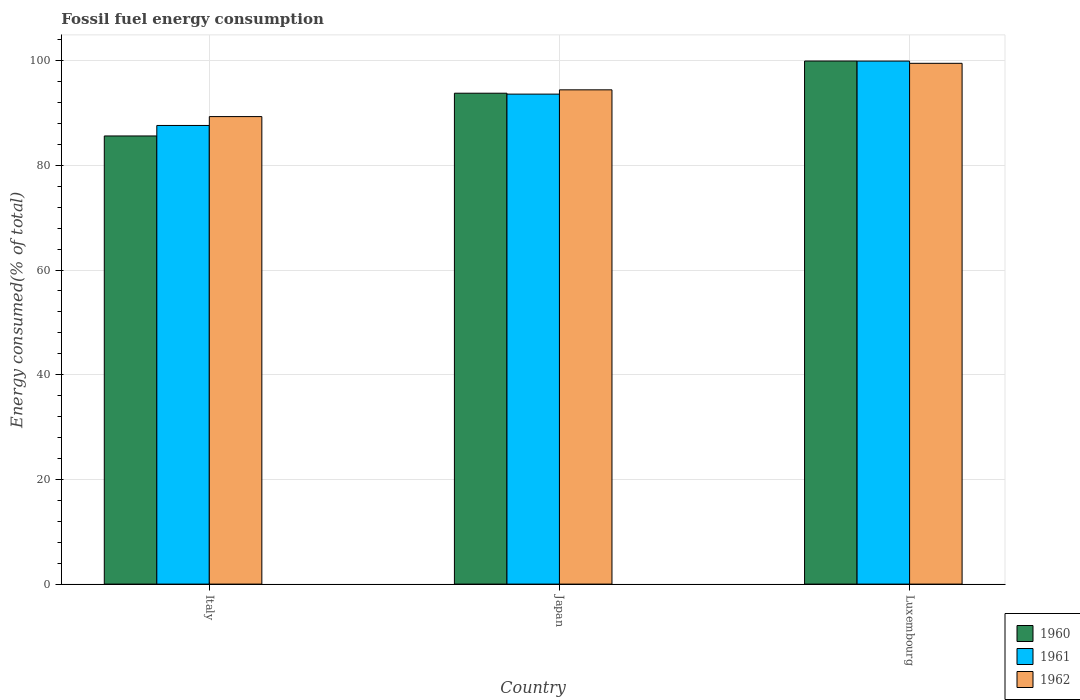How many groups of bars are there?
Make the answer very short. 3. Are the number of bars on each tick of the X-axis equal?
Keep it short and to the point. Yes. How many bars are there on the 3rd tick from the left?
Ensure brevity in your answer.  3. In how many cases, is the number of bars for a given country not equal to the number of legend labels?
Offer a very short reply. 0. What is the percentage of energy consumed in 1960 in Japan?
Ensure brevity in your answer.  93.78. Across all countries, what is the maximum percentage of energy consumed in 1960?
Keep it short and to the point. 99.92. Across all countries, what is the minimum percentage of energy consumed in 1962?
Make the answer very short. 89.31. In which country was the percentage of energy consumed in 1962 maximum?
Your response must be concise. Luxembourg. In which country was the percentage of energy consumed in 1960 minimum?
Your answer should be compact. Italy. What is the total percentage of energy consumed in 1961 in the graph?
Offer a terse response. 281.13. What is the difference between the percentage of energy consumed in 1960 in Japan and that in Luxembourg?
Offer a very short reply. -6.15. What is the difference between the percentage of energy consumed in 1961 in Italy and the percentage of energy consumed in 1962 in Luxembourg?
Offer a very short reply. -11.87. What is the average percentage of energy consumed in 1961 per country?
Your response must be concise. 93.71. What is the difference between the percentage of energy consumed of/in 1961 and percentage of energy consumed of/in 1962 in Japan?
Your answer should be very brief. -0.82. In how many countries, is the percentage of energy consumed in 1960 greater than 68 %?
Your answer should be very brief. 3. What is the ratio of the percentage of energy consumed in 1960 in Italy to that in Japan?
Offer a terse response. 0.91. Is the difference between the percentage of energy consumed in 1961 in Japan and Luxembourg greater than the difference between the percentage of energy consumed in 1962 in Japan and Luxembourg?
Your answer should be very brief. No. What is the difference between the highest and the second highest percentage of energy consumed in 1960?
Provide a short and direct response. 14.31. What is the difference between the highest and the lowest percentage of energy consumed in 1961?
Make the answer very short. 12.3. What does the 1st bar from the left in Italy represents?
Make the answer very short. 1960. What does the 3rd bar from the right in Luxembourg represents?
Your response must be concise. 1960. Is it the case that in every country, the sum of the percentage of energy consumed in 1962 and percentage of energy consumed in 1960 is greater than the percentage of energy consumed in 1961?
Keep it short and to the point. Yes. How many countries are there in the graph?
Provide a succinct answer. 3. What is the difference between two consecutive major ticks on the Y-axis?
Provide a short and direct response. 20. Are the values on the major ticks of Y-axis written in scientific E-notation?
Make the answer very short. No. Does the graph contain any zero values?
Offer a terse response. No. What is the title of the graph?
Give a very brief answer. Fossil fuel energy consumption. Does "1977" appear as one of the legend labels in the graph?
Make the answer very short. No. What is the label or title of the X-axis?
Give a very brief answer. Country. What is the label or title of the Y-axis?
Ensure brevity in your answer.  Energy consumed(% of total). What is the Energy consumed(% of total) of 1960 in Italy?
Make the answer very short. 85.61. What is the Energy consumed(% of total) in 1961 in Italy?
Provide a succinct answer. 87.62. What is the Energy consumed(% of total) in 1962 in Italy?
Provide a short and direct response. 89.31. What is the Energy consumed(% of total) of 1960 in Japan?
Your response must be concise. 93.78. What is the Energy consumed(% of total) in 1961 in Japan?
Your answer should be compact. 93.6. What is the Energy consumed(% of total) in 1962 in Japan?
Your response must be concise. 94.42. What is the Energy consumed(% of total) of 1960 in Luxembourg?
Make the answer very short. 99.92. What is the Energy consumed(% of total) of 1961 in Luxembourg?
Your answer should be very brief. 99.91. What is the Energy consumed(% of total) in 1962 in Luxembourg?
Your answer should be compact. 99.49. Across all countries, what is the maximum Energy consumed(% of total) in 1960?
Provide a succinct answer. 99.92. Across all countries, what is the maximum Energy consumed(% of total) in 1961?
Provide a succinct answer. 99.91. Across all countries, what is the maximum Energy consumed(% of total) of 1962?
Provide a succinct answer. 99.49. Across all countries, what is the minimum Energy consumed(% of total) in 1960?
Keep it short and to the point. 85.61. Across all countries, what is the minimum Energy consumed(% of total) in 1961?
Your answer should be very brief. 87.62. Across all countries, what is the minimum Energy consumed(% of total) in 1962?
Offer a terse response. 89.31. What is the total Energy consumed(% of total) in 1960 in the graph?
Keep it short and to the point. 279.31. What is the total Energy consumed(% of total) in 1961 in the graph?
Give a very brief answer. 281.13. What is the total Energy consumed(% of total) of 1962 in the graph?
Make the answer very short. 283.22. What is the difference between the Energy consumed(% of total) in 1960 in Italy and that in Japan?
Keep it short and to the point. -8.17. What is the difference between the Energy consumed(% of total) in 1961 in Italy and that in Japan?
Offer a terse response. -5.99. What is the difference between the Energy consumed(% of total) in 1962 in Italy and that in Japan?
Offer a very short reply. -5.11. What is the difference between the Energy consumed(% of total) in 1960 in Italy and that in Luxembourg?
Your answer should be compact. -14.31. What is the difference between the Energy consumed(% of total) in 1961 in Italy and that in Luxembourg?
Ensure brevity in your answer.  -12.3. What is the difference between the Energy consumed(% of total) in 1962 in Italy and that in Luxembourg?
Offer a very short reply. -10.18. What is the difference between the Energy consumed(% of total) in 1960 in Japan and that in Luxembourg?
Provide a succinct answer. -6.15. What is the difference between the Energy consumed(% of total) of 1961 in Japan and that in Luxembourg?
Your answer should be compact. -6.31. What is the difference between the Energy consumed(% of total) of 1962 in Japan and that in Luxembourg?
Offer a very short reply. -5.07. What is the difference between the Energy consumed(% of total) of 1960 in Italy and the Energy consumed(% of total) of 1961 in Japan?
Make the answer very short. -7.99. What is the difference between the Energy consumed(% of total) of 1960 in Italy and the Energy consumed(% of total) of 1962 in Japan?
Give a very brief answer. -8.81. What is the difference between the Energy consumed(% of total) of 1961 in Italy and the Energy consumed(% of total) of 1962 in Japan?
Your answer should be very brief. -6.8. What is the difference between the Energy consumed(% of total) of 1960 in Italy and the Energy consumed(% of total) of 1961 in Luxembourg?
Make the answer very short. -14.3. What is the difference between the Energy consumed(% of total) of 1960 in Italy and the Energy consumed(% of total) of 1962 in Luxembourg?
Offer a terse response. -13.88. What is the difference between the Energy consumed(% of total) of 1961 in Italy and the Energy consumed(% of total) of 1962 in Luxembourg?
Your answer should be compact. -11.87. What is the difference between the Energy consumed(% of total) in 1960 in Japan and the Energy consumed(% of total) in 1961 in Luxembourg?
Provide a succinct answer. -6.14. What is the difference between the Energy consumed(% of total) of 1960 in Japan and the Energy consumed(% of total) of 1962 in Luxembourg?
Provide a short and direct response. -5.71. What is the difference between the Energy consumed(% of total) in 1961 in Japan and the Energy consumed(% of total) in 1962 in Luxembourg?
Offer a very short reply. -5.88. What is the average Energy consumed(% of total) in 1960 per country?
Your response must be concise. 93.1. What is the average Energy consumed(% of total) of 1961 per country?
Provide a succinct answer. 93.71. What is the average Energy consumed(% of total) in 1962 per country?
Your answer should be compact. 94.41. What is the difference between the Energy consumed(% of total) of 1960 and Energy consumed(% of total) of 1961 in Italy?
Ensure brevity in your answer.  -2.01. What is the difference between the Energy consumed(% of total) of 1960 and Energy consumed(% of total) of 1962 in Italy?
Make the answer very short. -3.7. What is the difference between the Energy consumed(% of total) in 1961 and Energy consumed(% of total) in 1962 in Italy?
Offer a terse response. -1.69. What is the difference between the Energy consumed(% of total) of 1960 and Energy consumed(% of total) of 1961 in Japan?
Your answer should be very brief. 0.17. What is the difference between the Energy consumed(% of total) of 1960 and Energy consumed(% of total) of 1962 in Japan?
Offer a terse response. -0.64. What is the difference between the Energy consumed(% of total) in 1961 and Energy consumed(% of total) in 1962 in Japan?
Provide a short and direct response. -0.82. What is the difference between the Energy consumed(% of total) of 1960 and Energy consumed(% of total) of 1961 in Luxembourg?
Your response must be concise. 0.01. What is the difference between the Energy consumed(% of total) in 1960 and Energy consumed(% of total) in 1962 in Luxembourg?
Your answer should be compact. 0.44. What is the difference between the Energy consumed(% of total) of 1961 and Energy consumed(% of total) of 1962 in Luxembourg?
Make the answer very short. 0.42. What is the ratio of the Energy consumed(% of total) in 1960 in Italy to that in Japan?
Your answer should be very brief. 0.91. What is the ratio of the Energy consumed(% of total) in 1961 in Italy to that in Japan?
Your answer should be very brief. 0.94. What is the ratio of the Energy consumed(% of total) in 1962 in Italy to that in Japan?
Your answer should be compact. 0.95. What is the ratio of the Energy consumed(% of total) in 1960 in Italy to that in Luxembourg?
Offer a very short reply. 0.86. What is the ratio of the Energy consumed(% of total) in 1961 in Italy to that in Luxembourg?
Offer a terse response. 0.88. What is the ratio of the Energy consumed(% of total) of 1962 in Italy to that in Luxembourg?
Your response must be concise. 0.9. What is the ratio of the Energy consumed(% of total) in 1960 in Japan to that in Luxembourg?
Provide a short and direct response. 0.94. What is the ratio of the Energy consumed(% of total) of 1961 in Japan to that in Luxembourg?
Your answer should be very brief. 0.94. What is the ratio of the Energy consumed(% of total) in 1962 in Japan to that in Luxembourg?
Provide a succinct answer. 0.95. What is the difference between the highest and the second highest Energy consumed(% of total) of 1960?
Offer a terse response. 6.15. What is the difference between the highest and the second highest Energy consumed(% of total) of 1961?
Provide a short and direct response. 6.31. What is the difference between the highest and the second highest Energy consumed(% of total) of 1962?
Keep it short and to the point. 5.07. What is the difference between the highest and the lowest Energy consumed(% of total) in 1960?
Ensure brevity in your answer.  14.31. What is the difference between the highest and the lowest Energy consumed(% of total) in 1961?
Your answer should be very brief. 12.3. What is the difference between the highest and the lowest Energy consumed(% of total) in 1962?
Keep it short and to the point. 10.18. 